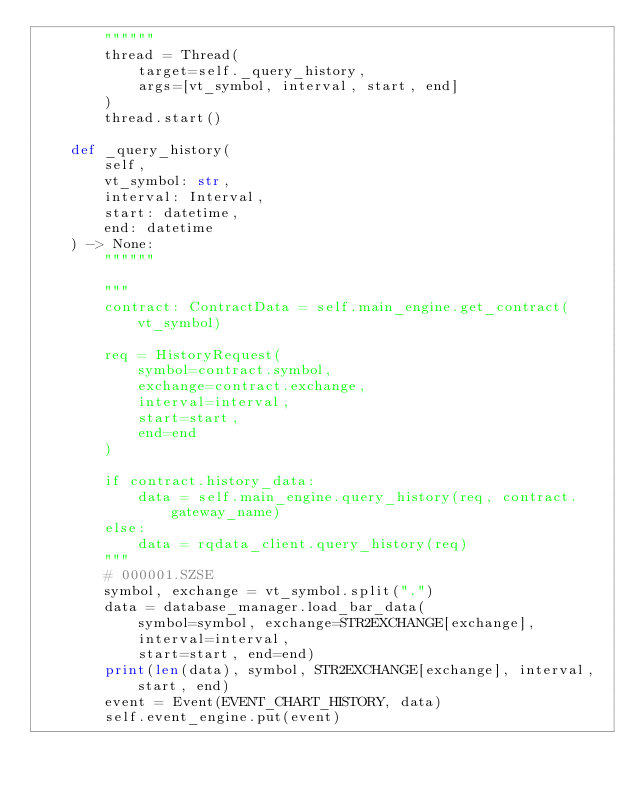<code> <loc_0><loc_0><loc_500><loc_500><_Python_>        """"""
        thread = Thread(
            target=self._query_history,
            args=[vt_symbol, interval, start, end]
        )
        thread.start()

    def _query_history(
        self,
        vt_symbol: str,
        interval: Interval,
        start: datetime,
        end: datetime
    ) -> None:
        """"""

        """
        contract: ContractData = self.main_engine.get_contract(vt_symbol)

        req = HistoryRequest(
            symbol=contract.symbol,
            exchange=contract.exchange,
            interval=interval,
            start=start,
            end=end
        )

        if contract.history_data:
            data = self.main_engine.query_history(req, contract.gateway_name)
        else:
            data = rqdata_client.query_history(req)
        """
        # 000001.SZSE
        symbol, exchange = vt_symbol.split(".")
        data = database_manager.load_bar_data(
            symbol=symbol, exchange=STR2EXCHANGE[exchange],
            interval=interval,
            start=start, end=end)
        print(len(data), symbol, STR2EXCHANGE[exchange], interval, start, end)
        event = Event(EVENT_CHART_HISTORY, data)
        self.event_engine.put(event)
</code> 